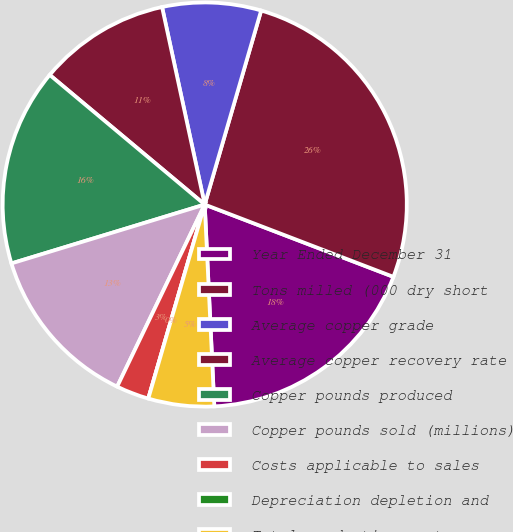<chart> <loc_0><loc_0><loc_500><loc_500><pie_chart><fcel>Year Ended December 31<fcel>Tons milled (000 dry short<fcel>Average copper grade<fcel>Average copper recovery rate<fcel>Copper pounds produced<fcel>Copper pounds sold (millions)<fcel>Costs applicable to sales<fcel>Depreciation depletion and<fcel>Total production costs<nl><fcel>18.42%<fcel>26.32%<fcel>7.89%<fcel>10.53%<fcel>15.79%<fcel>13.16%<fcel>2.63%<fcel>0.0%<fcel>5.26%<nl></chart> 